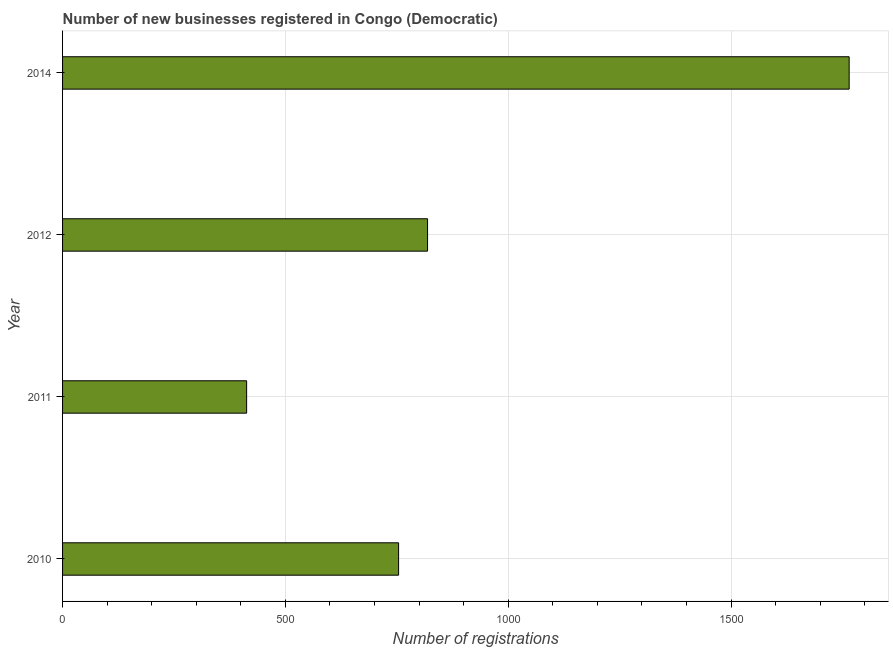Does the graph contain any zero values?
Your response must be concise. No. What is the title of the graph?
Keep it short and to the point. Number of new businesses registered in Congo (Democratic). What is the label or title of the X-axis?
Provide a succinct answer. Number of registrations. What is the number of new business registrations in 2012?
Keep it short and to the point. 819. Across all years, what is the maximum number of new business registrations?
Give a very brief answer. 1765. Across all years, what is the minimum number of new business registrations?
Keep it short and to the point. 413. In which year was the number of new business registrations minimum?
Offer a very short reply. 2011. What is the sum of the number of new business registrations?
Offer a terse response. 3751. What is the difference between the number of new business registrations in 2010 and 2014?
Your answer should be compact. -1011. What is the average number of new business registrations per year?
Your response must be concise. 937. What is the median number of new business registrations?
Your response must be concise. 786.5. In how many years, is the number of new business registrations greater than 1600 ?
Your answer should be compact. 1. What is the ratio of the number of new business registrations in 2011 to that in 2012?
Make the answer very short. 0.5. What is the difference between the highest and the second highest number of new business registrations?
Your answer should be compact. 946. Is the sum of the number of new business registrations in 2012 and 2014 greater than the maximum number of new business registrations across all years?
Ensure brevity in your answer.  Yes. What is the difference between the highest and the lowest number of new business registrations?
Provide a succinct answer. 1352. Are all the bars in the graph horizontal?
Your response must be concise. Yes. What is the difference between two consecutive major ticks on the X-axis?
Provide a succinct answer. 500. Are the values on the major ticks of X-axis written in scientific E-notation?
Your answer should be compact. No. What is the Number of registrations of 2010?
Provide a short and direct response. 754. What is the Number of registrations of 2011?
Ensure brevity in your answer.  413. What is the Number of registrations of 2012?
Offer a terse response. 819. What is the Number of registrations of 2014?
Make the answer very short. 1765. What is the difference between the Number of registrations in 2010 and 2011?
Ensure brevity in your answer.  341. What is the difference between the Number of registrations in 2010 and 2012?
Your answer should be compact. -65. What is the difference between the Number of registrations in 2010 and 2014?
Offer a terse response. -1011. What is the difference between the Number of registrations in 2011 and 2012?
Give a very brief answer. -406. What is the difference between the Number of registrations in 2011 and 2014?
Offer a very short reply. -1352. What is the difference between the Number of registrations in 2012 and 2014?
Your answer should be compact. -946. What is the ratio of the Number of registrations in 2010 to that in 2011?
Your answer should be very brief. 1.83. What is the ratio of the Number of registrations in 2010 to that in 2012?
Give a very brief answer. 0.92. What is the ratio of the Number of registrations in 2010 to that in 2014?
Provide a succinct answer. 0.43. What is the ratio of the Number of registrations in 2011 to that in 2012?
Offer a very short reply. 0.5. What is the ratio of the Number of registrations in 2011 to that in 2014?
Provide a short and direct response. 0.23. What is the ratio of the Number of registrations in 2012 to that in 2014?
Ensure brevity in your answer.  0.46. 